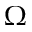<formula> <loc_0><loc_0><loc_500><loc_500>\Omega</formula> 